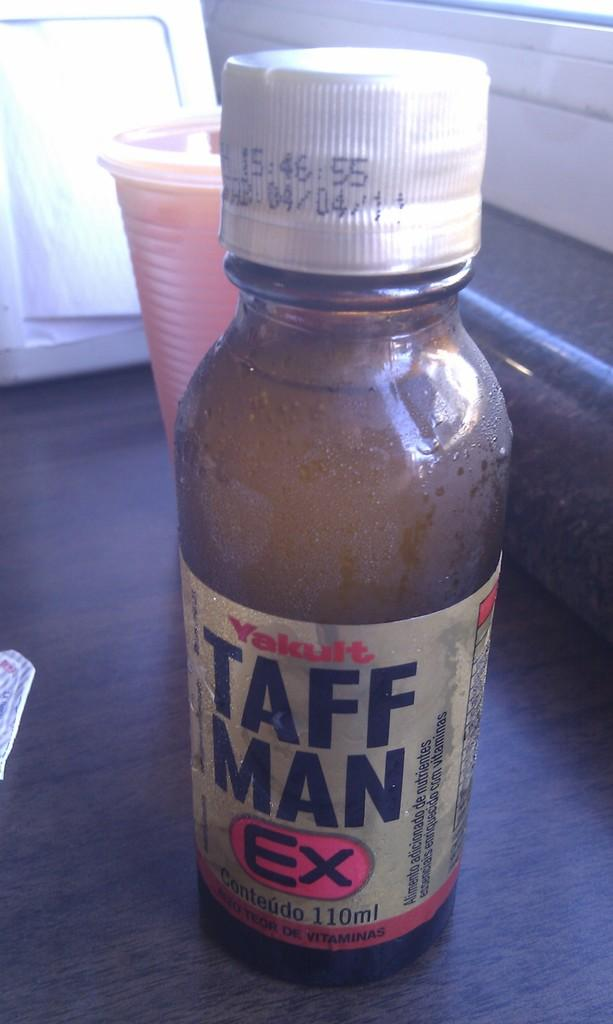<image>
Share a concise interpretation of the image provided. A bottle of Taff Man Ex contains 110 ml of liquid. 